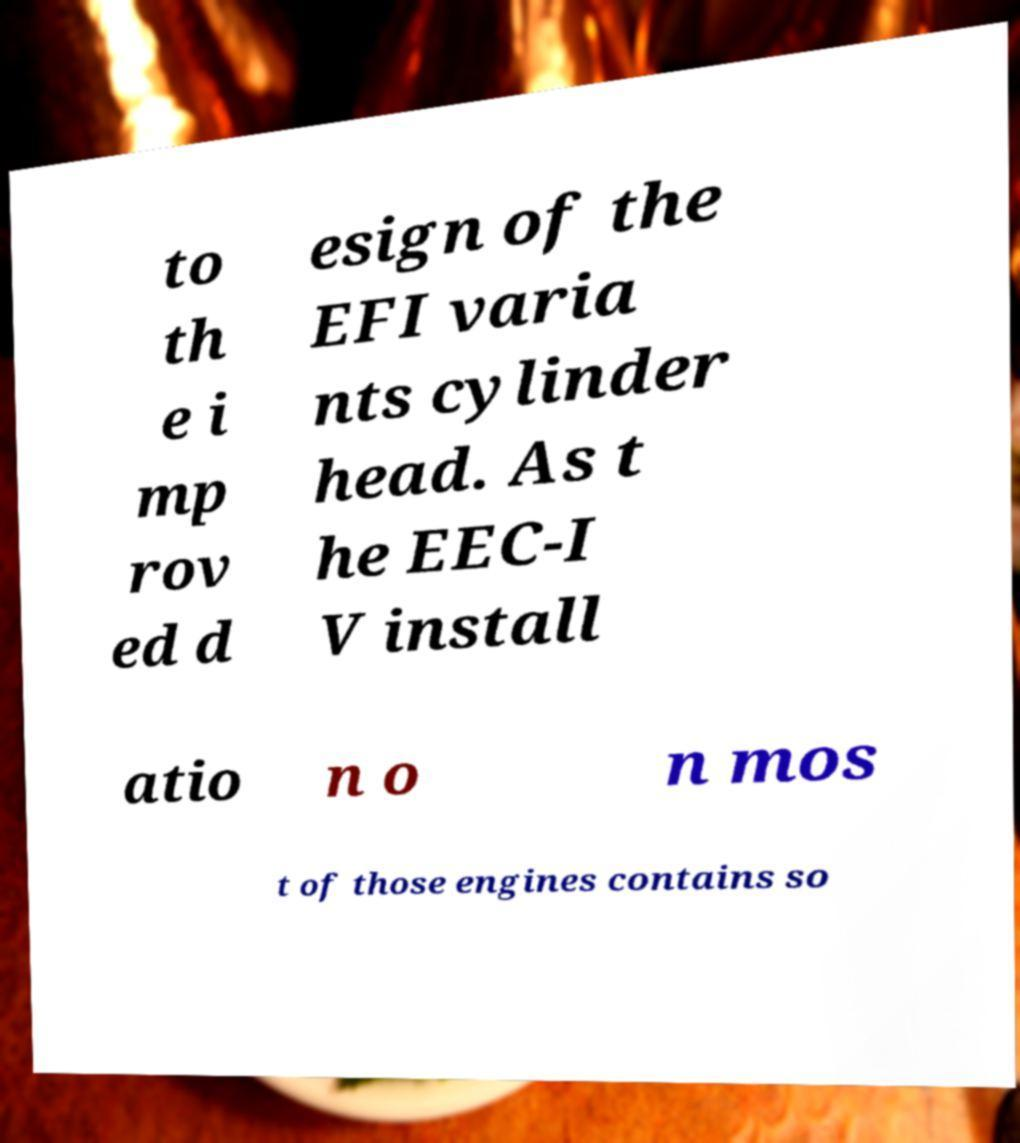Can you accurately transcribe the text from the provided image for me? to th e i mp rov ed d esign of the EFI varia nts cylinder head. As t he EEC-I V install atio n o n mos t of those engines contains so 